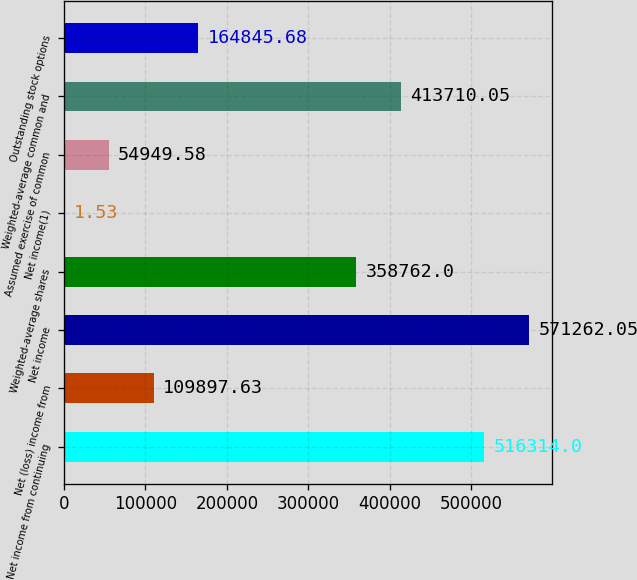<chart> <loc_0><loc_0><loc_500><loc_500><bar_chart><fcel>Net income from continuing<fcel>Net (loss) income from<fcel>Net income<fcel>Weighted-average shares<fcel>Net income(1)<fcel>Assumed exercise of common<fcel>Weighted-average common and<fcel>Outstanding stock options<nl><fcel>516314<fcel>109898<fcel>571262<fcel>358762<fcel>1.53<fcel>54949.6<fcel>413710<fcel>164846<nl></chart> 